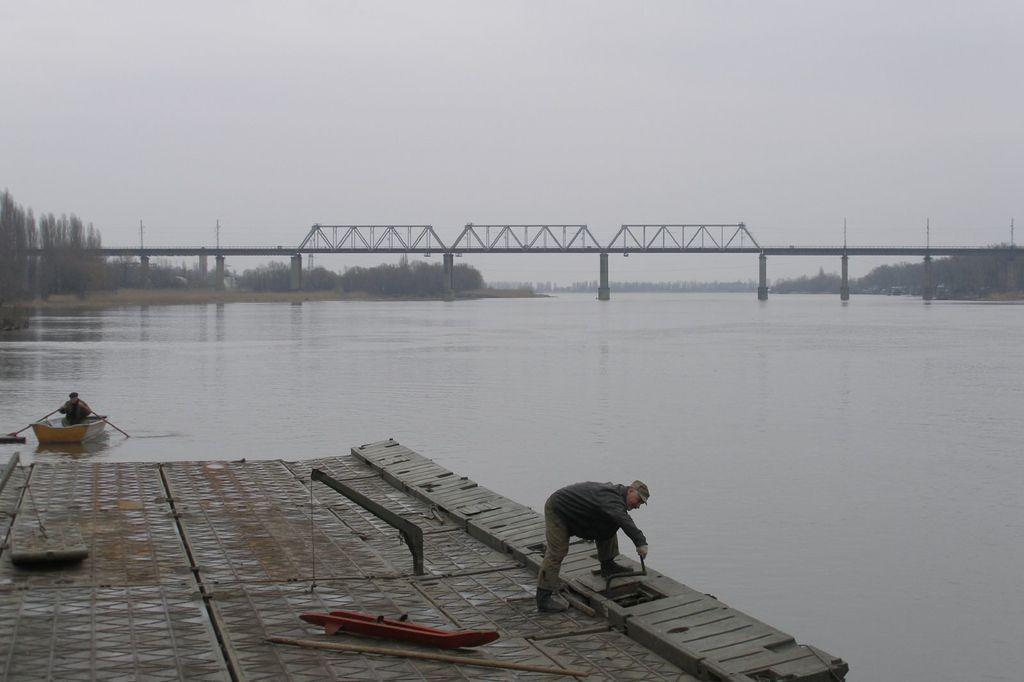Describe this image in one or two sentences. At the bottom of the image there is a floor and on the floor there is a man. There is water with boat and on the boat there is a man. Also there is a bridge across the water with pillars. In the background there are trees. At the top of the image there is a sky. 